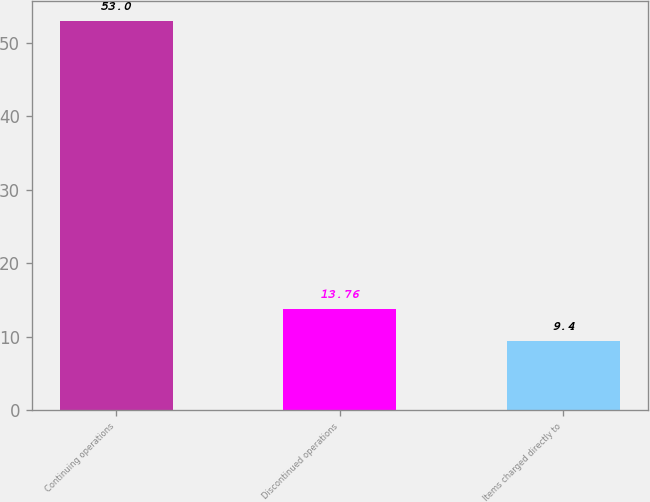<chart> <loc_0><loc_0><loc_500><loc_500><bar_chart><fcel>Continuing operations<fcel>Discontinued operations<fcel>Items charged directly to<nl><fcel>53<fcel>13.76<fcel>9.4<nl></chart> 